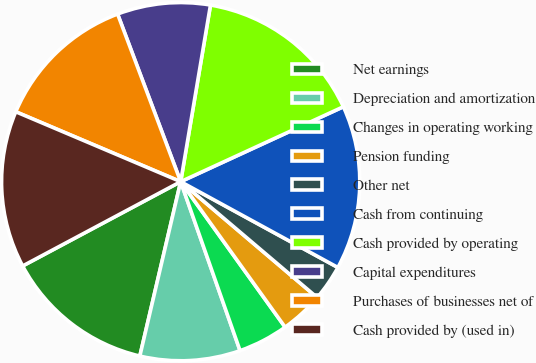Convert chart. <chart><loc_0><loc_0><loc_500><loc_500><pie_chart><fcel>Net earnings<fcel>Depreciation and amortization<fcel>Changes in operating working<fcel>Pension funding<fcel>Other net<fcel>Cash from continuing<fcel>Cash provided by operating<fcel>Capital expenditures<fcel>Purchases of businesses net of<fcel>Cash provided by (used in)<nl><fcel>13.54%<fcel>9.04%<fcel>4.53%<fcel>3.89%<fcel>3.25%<fcel>14.82%<fcel>15.47%<fcel>8.39%<fcel>12.89%<fcel>14.18%<nl></chart> 